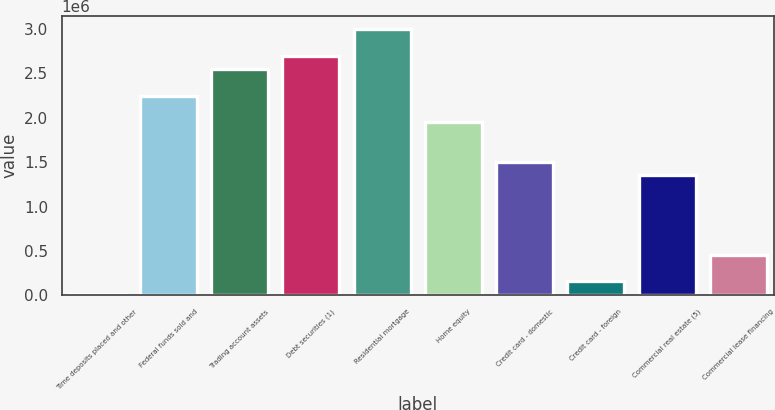<chart> <loc_0><loc_0><loc_500><loc_500><bar_chart><fcel>Time deposits placed and other<fcel>Federal funds sold and<fcel>Trading account assets<fcel>Debt securities (1)<fcel>Residential mortgage<fcel>Home equity<fcel>Credit card - domestic<fcel>Credit card - foreign<fcel>Commercial real estate (5)<fcel>Commercial lease financing<nl><fcel>10459<fcel>2.24927e+06<fcel>2.54778e+06<fcel>2.69703e+06<fcel>2.99554e+06<fcel>1.95076e+06<fcel>1.503e+06<fcel>159713<fcel>1.35374e+06<fcel>458221<nl></chart> 